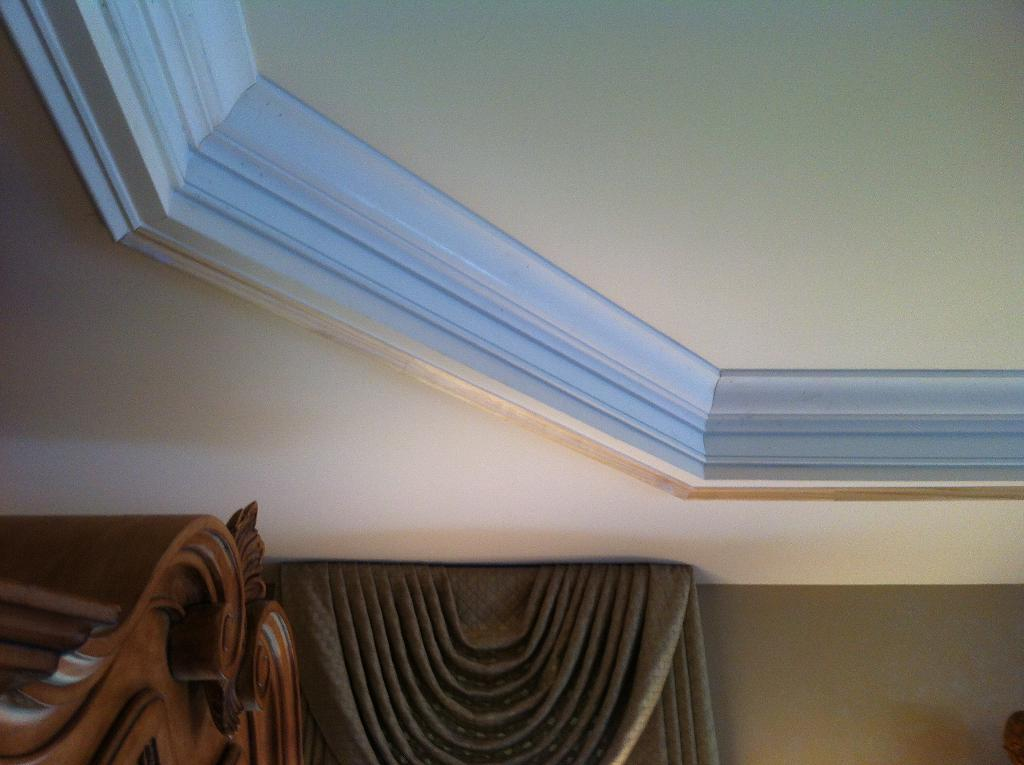What type of structure can be seen in the image? There is a wall in the image. What is above the wall in the image? There is a ceiling in the image. What type of window treatment is present in the image? There is a curtain in the image. Can you describe the object in the image? There is an object in the image, but its specific details are not mentioned in the provided facts. How many dinosaurs are visible in the image? There are no dinosaurs present in the image. What type of star is featured in the image? There is no star present in the image. 